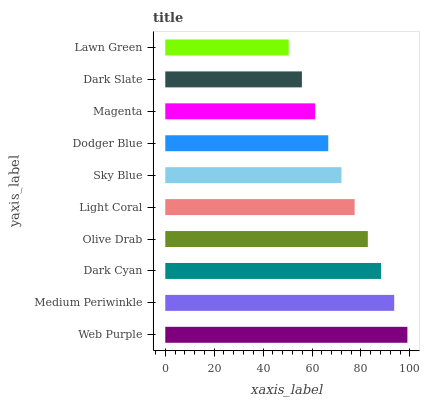Is Lawn Green the minimum?
Answer yes or no. Yes. Is Web Purple the maximum?
Answer yes or no. Yes. Is Medium Periwinkle the minimum?
Answer yes or no. No. Is Medium Periwinkle the maximum?
Answer yes or no. No. Is Web Purple greater than Medium Periwinkle?
Answer yes or no. Yes. Is Medium Periwinkle less than Web Purple?
Answer yes or no. Yes. Is Medium Periwinkle greater than Web Purple?
Answer yes or no. No. Is Web Purple less than Medium Periwinkle?
Answer yes or no. No. Is Light Coral the high median?
Answer yes or no. Yes. Is Sky Blue the low median?
Answer yes or no. Yes. Is Magenta the high median?
Answer yes or no. No. Is Medium Periwinkle the low median?
Answer yes or no. No. 